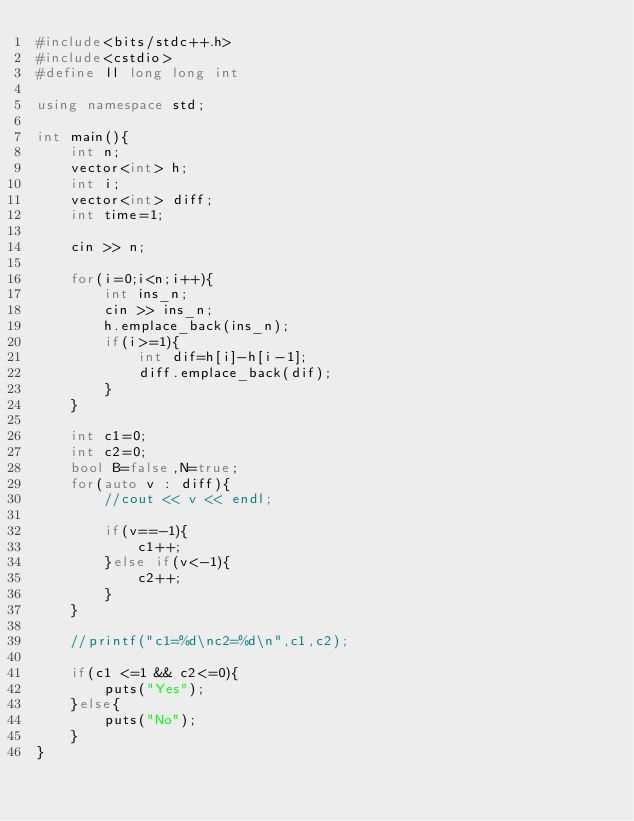Convert code to text. <code><loc_0><loc_0><loc_500><loc_500><_C++_>#include<bits/stdc++.h>
#include<cstdio>
#define ll long long int

using namespace std;

int main(){
    int n;
    vector<int> h;
    int i;
    vector<int> diff;
    int time=1;
    
    cin >> n;

    for(i=0;i<n;i++){
        int ins_n;
        cin >> ins_n;
        h.emplace_back(ins_n);
        if(i>=1){
            int dif=h[i]-h[i-1];
            diff.emplace_back(dif);
        }
    }

    int c1=0;
    int c2=0;
    bool B=false,N=true;
    for(auto v : diff){
        //cout << v << endl;

        if(v==-1){
            c1++;
        }else if(v<-1){
            c2++;
        }
    }

    //printf("c1=%d\nc2=%d\n",c1,c2);

    if(c1 <=1 && c2<=0){
        puts("Yes");
    }else{
        puts("No");
    }
}</code> 